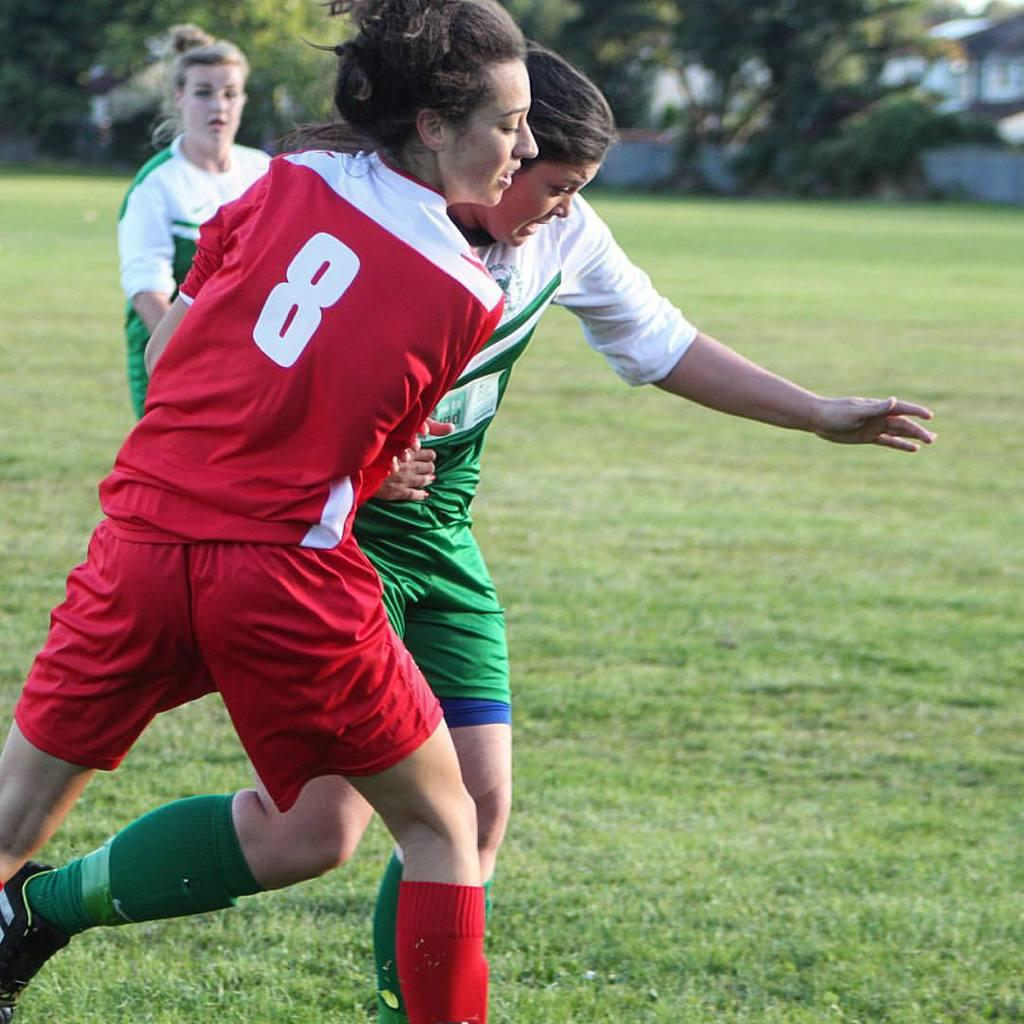<image>
Summarize the visual content of the image. Two girls battle on a soccer field, one of whom wears the number 8. 